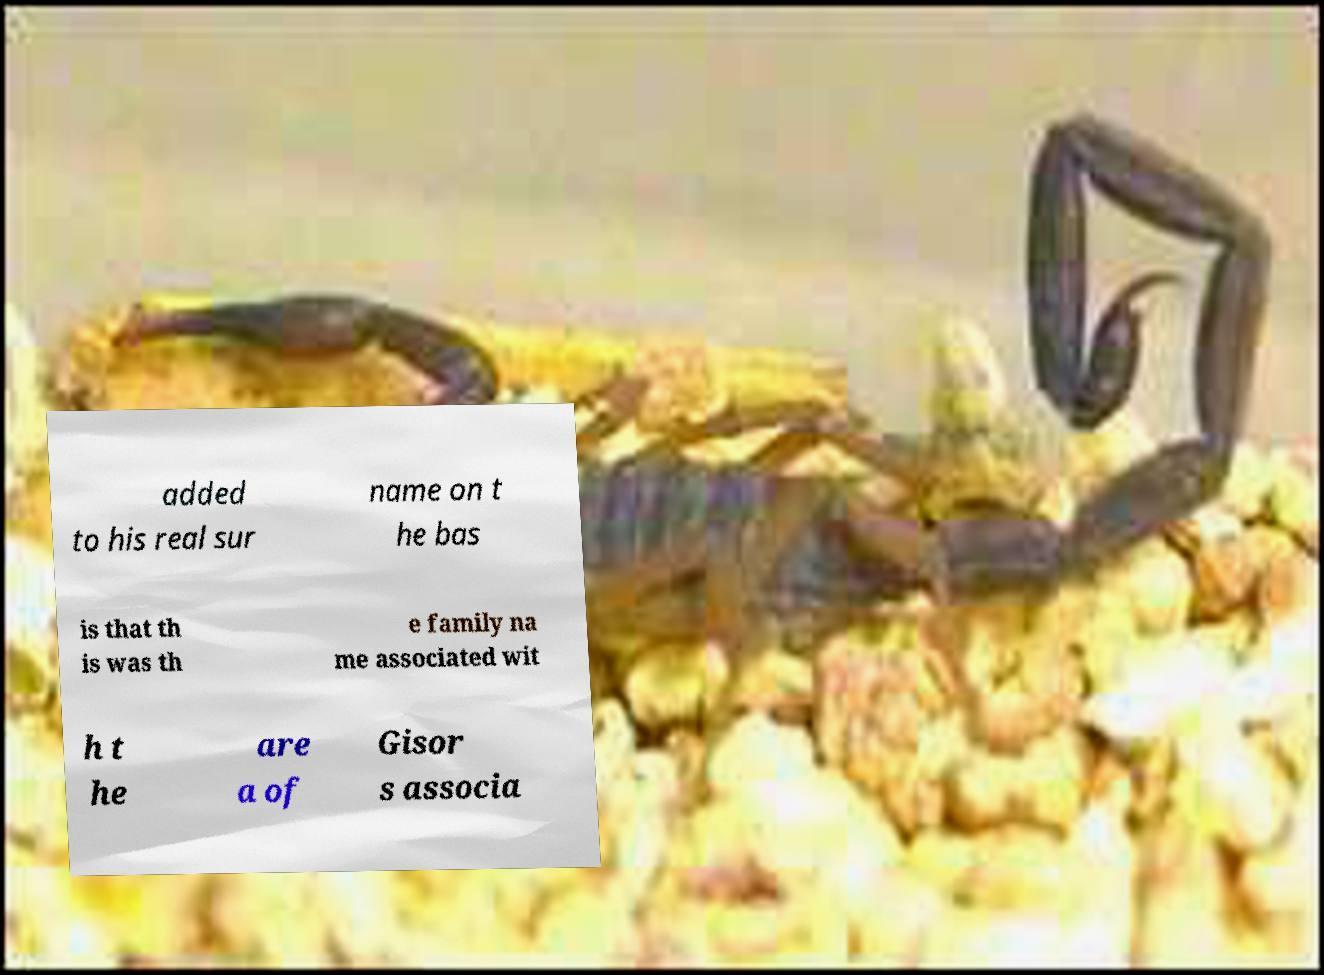Please identify and transcribe the text found in this image. added to his real sur name on t he bas is that th is was th e family na me associated wit h t he are a of Gisor s associa 